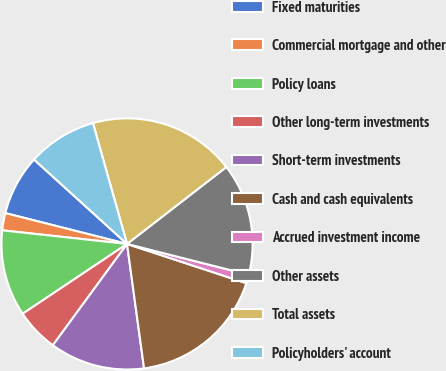Convert chart to OTSL. <chart><loc_0><loc_0><loc_500><loc_500><pie_chart><fcel>Fixed maturities<fcel>Commercial mortgage and other<fcel>Policy loans<fcel>Other long-term investments<fcel>Short-term investments<fcel>Cash and cash equivalents<fcel>Accrued investment income<fcel>Other assets<fcel>Total assets<fcel>Policyholders' account<nl><fcel>7.78%<fcel>2.22%<fcel>11.11%<fcel>5.56%<fcel>12.22%<fcel>17.78%<fcel>1.11%<fcel>14.44%<fcel>18.89%<fcel>8.89%<nl></chart> 